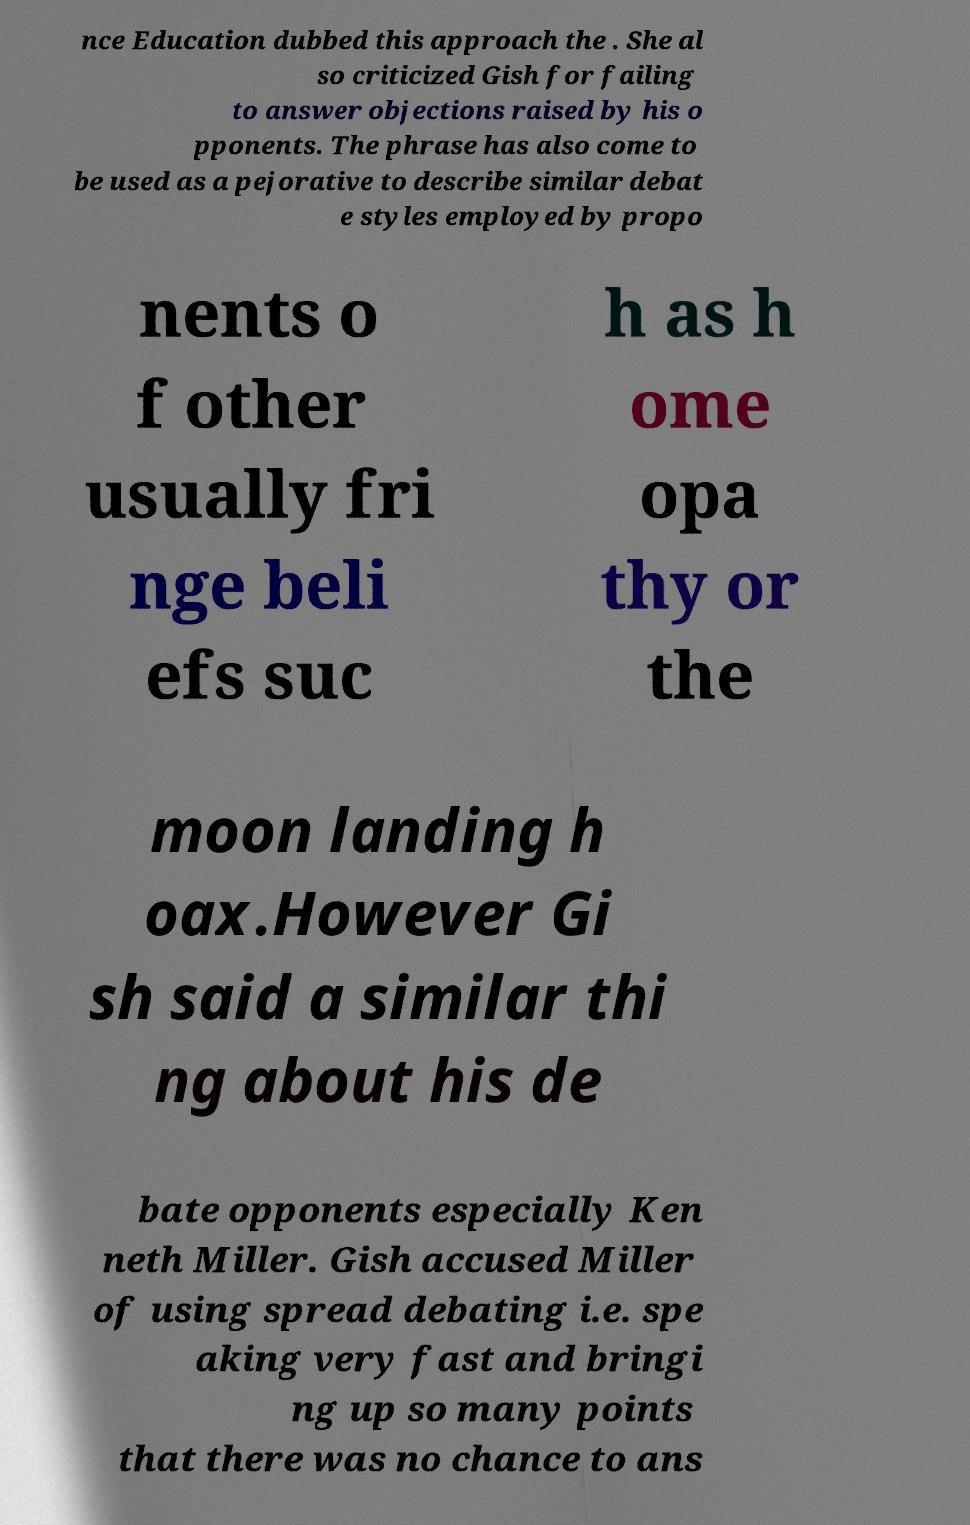Can you accurately transcribe the text from the provided image for me? nce Education dubbed this approach the . She al so criticized Gish for failing to answer objections raised by his o pponents. The phrase has also come to be used as a pejorative to describe similar debat e styles employed by propo nents o f other usually fri nge beli efs suc h as h ome opa thy or the moon landing h oax.However Gi sh said a similar thi ng about his de bate opponents especially Ken neth Miller. Gish accused Miller of using spread debating i.e. spe aking very fast and bringi ng up so many points that there was no chance to ans 